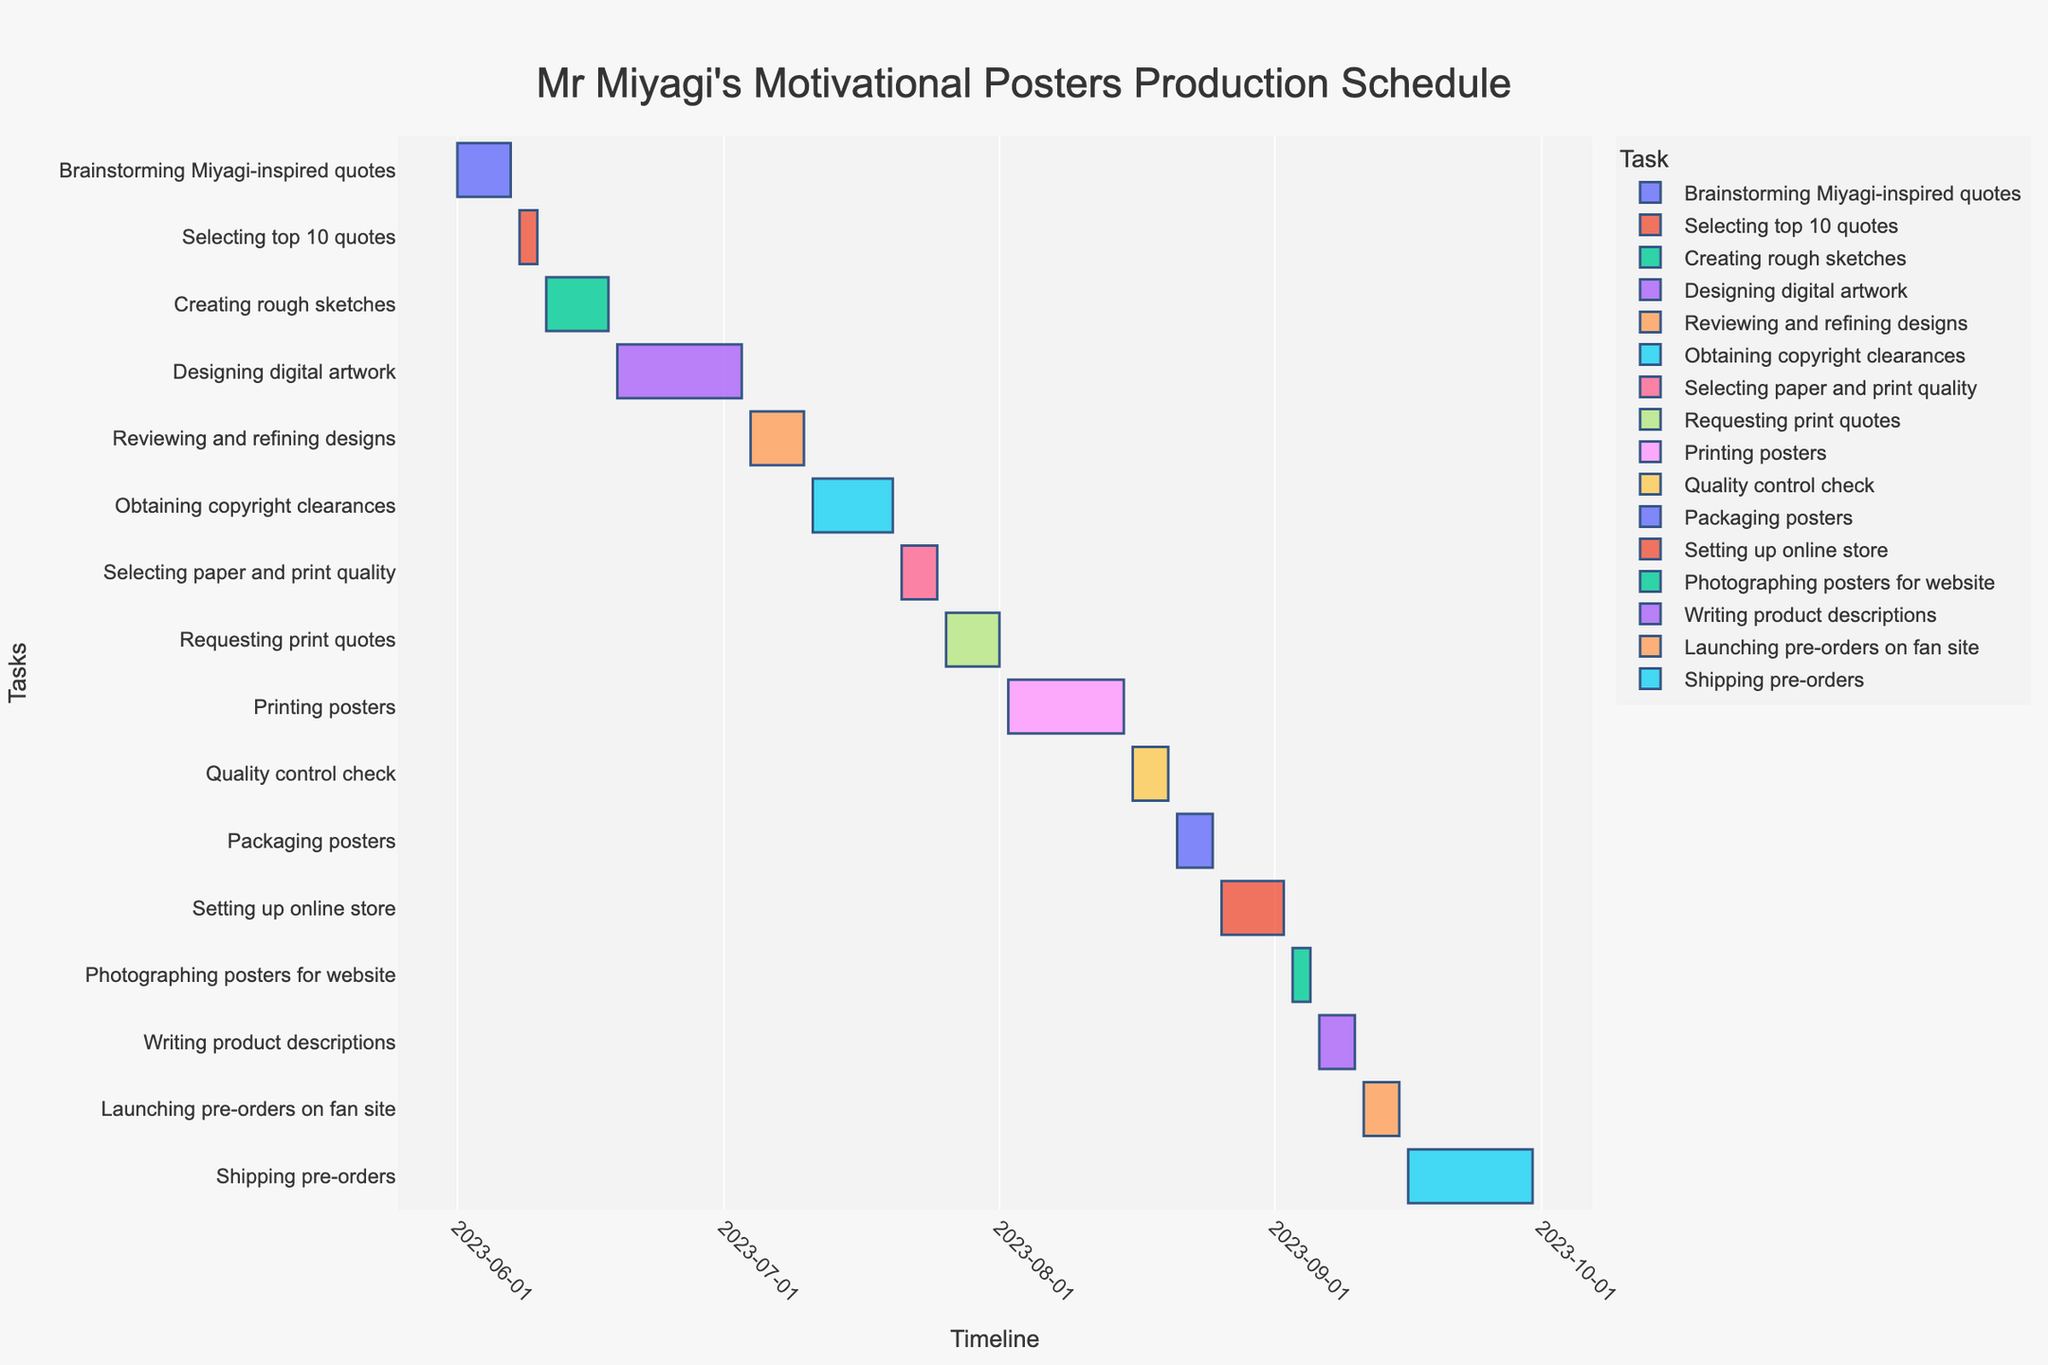What's the title of the Gantt chart? The title can be found at the very top of the Gantt chart. It is clearly labeled and stands out due to its prominent placement and larger font size.
Answer: "Mr Miyagi's Motivational Posters Production Schedule" What task starts immediately after "Brainstorming Miyagi-inspired quotes"? Find the task bar labeled "Brainstorming Miyagi-inspired quotes" and then look for the next task bar that starts after the end of this task. Validating the dates can help ensure accuracy.
Answer: Selecting top 10 quotes How long is the "Printing posters" task? Locate the "Printing posters" task on the y-axis, then note its start and end dates on the x-axis. Subtracting these dates will give the task duration.
Answer: 14 days What is the total number of tasks in the schedule? Count each unique task labeled on the y-axis of the Gantt chart. Each task has a corresponding bar that spans from its start to end date.
Answer: 16 Which task has the shortest duration, and how many days does it span? Compare the lengths of all bars visually or check the hover information for each task to find the shortest duration.
Answer: Selecting top 10 quotes, 3 days When does the "Reviewing and refining designs" task start and end? Locate the "Reviewing and refining designs" task on the y-axis and then identify its start and end points on the x-axis timeline.
Answer: Starts on 2023-07-04 and ends on 2023-07-10 Which task finishes before the "Selecting paper and print quality" task begins? Find the starting date of the "Selecting paper and print quality" task and look for tasks that end just before this start date.
Answer: Obtaining copyright clearances How long is the time span from the start of "Brainstorming Miyagi-inspired quotes" to the end of "Shipping pre-orders"? Note the start date of "Brainstorming Miyagi-inspired quotes" and the end date of "Shipping pre-orders" then calculate the number of days between these two dates.
Answer: 122 days Are there any tasks that overlap with the "Packaging posters" task? Identify the duration of the "Packaging posters" task and compare it visually with the other tasks to see if any timelines overlap.
Answer: Yes, "Setting up online store" Which task ends right before "Requesting print quotes" begins? Check the start date of "Requesting print quotes" and find which task ends on the day before or on the same day.
Answer: Selecting paper and print quality 